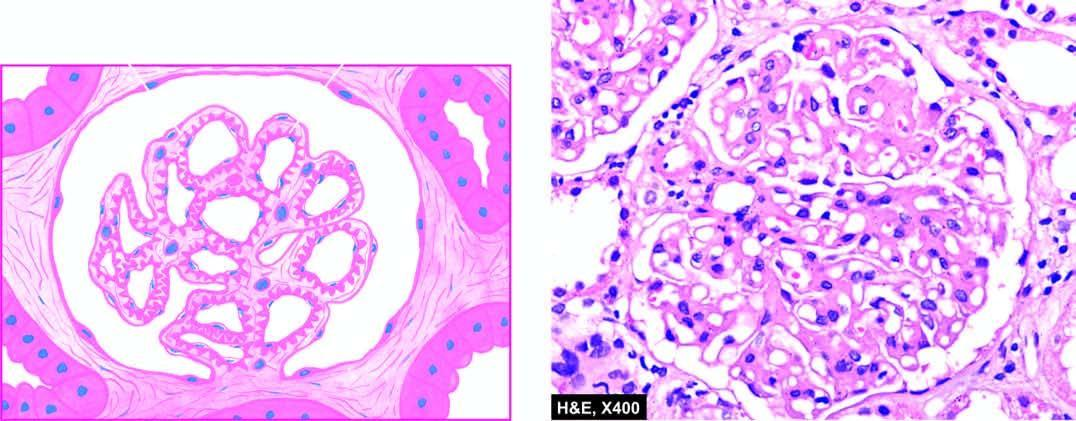re layers of squamous epithelium diffusely thickened due to duplication of the gbm?
Answer the question using a single word or phrase. No 